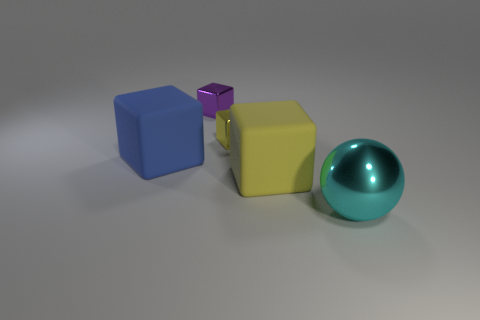Is there a purple block that has the same material as the cyan thing?
Ensure brevity in your answer.  Yes. Is there a yellow metal cube left of the large matte thing on the right side of the small purple thing that is on the right side of the large blue rubber thing?
Offer a very short reply. Yes. What number of other objects are the same shape as the cyan shiny object?
Provide a succinct answer. 0. There is a metal thing in front of the matte block on the right side of the big object left of the purple object; what color is it?
Keep it short and to the point. Cyan. What number of tiny yellow metallic objects are there?
Make the answer very short. 1. How many big objects are either cyan objects or yellow cubes?
Give a very brief answer. 2. There is a blue thing that is the same size as the cyan metallic thing; what shape is it?
Your response must be concise. Cube. There is a yellow cube that is in front of the tiny yellow block to the right of the blue rubber cube; what is it made of?
Provide a short and direct response. Rubber. Is the size of the yellow matte thing the same as the cyan shiny object?
Your answer should be very brief. Yes. How many objects are rubber blocks right of the small yellow block or big rubber things?
Your response must be concise. 2. 